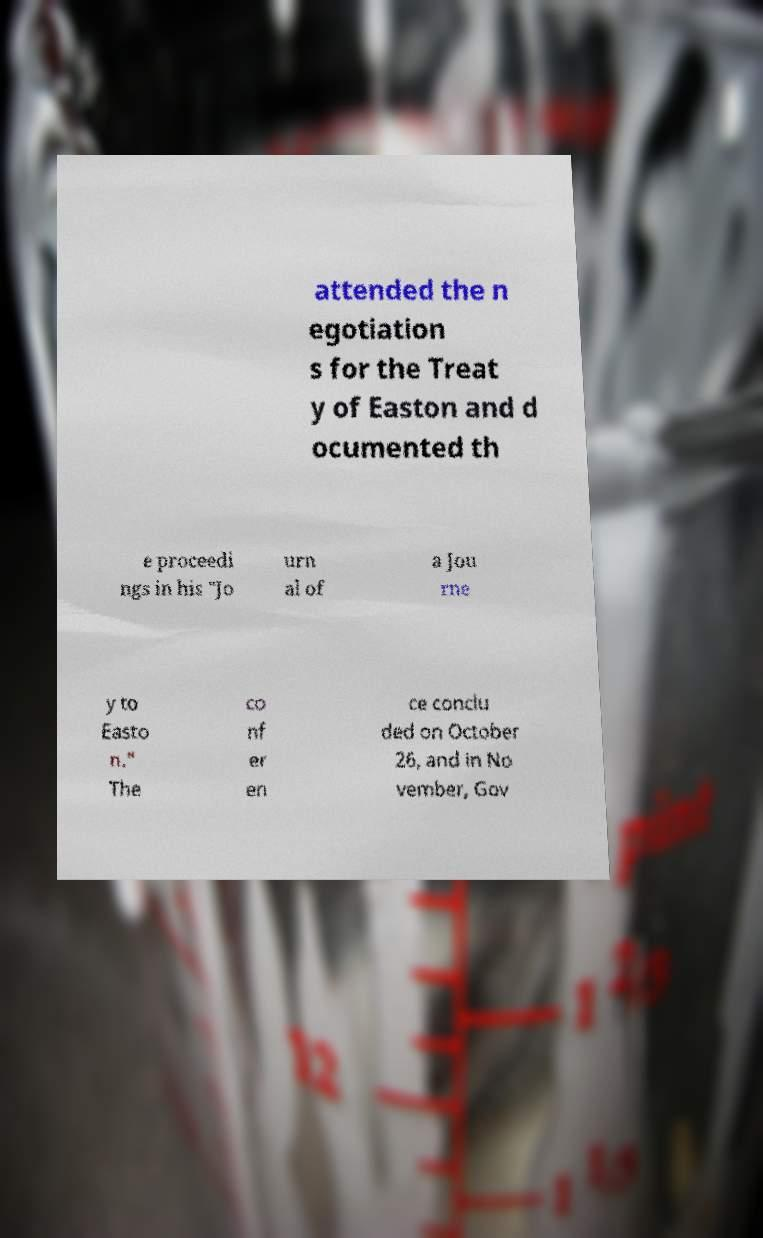Can you read and provide the text displayed in the image?This photo seems to have some interesting text. Can you extract and type it out for me? attended the n egotiation s for the Treat y of Easton and d ocumented th e proceedi ngs in his "Jo urn al of a Jou rne y to Easto n." The co nf er en ce conclu ded on October 26, and in No vember, Gov 